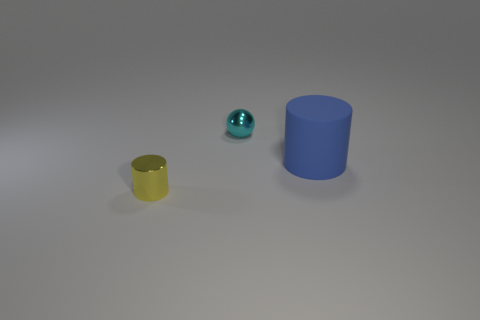Could you describe the lighting and shadows in the image? The lighting in the image appears to be soft and diffused, coming from the upper left as indicated by the shadows. Each object casts a gentle shadow to the right, implying a single light source that isn't overly harsh or direct. 